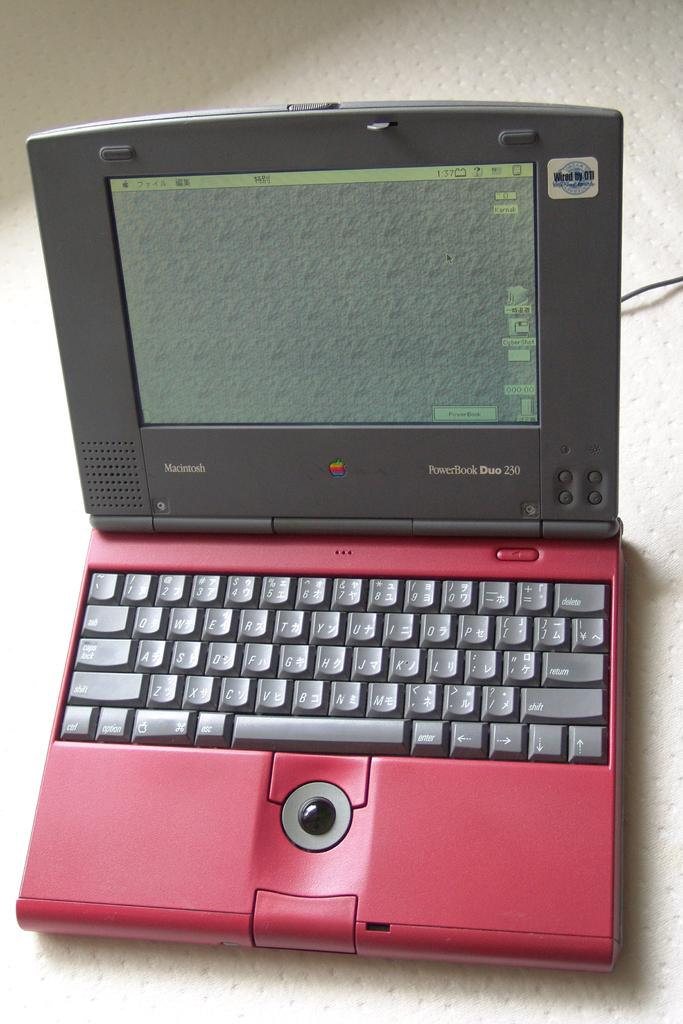<image>
Render a clear and concise summary of the photo. A red and grey laptop called a PowerBook Duo 230 